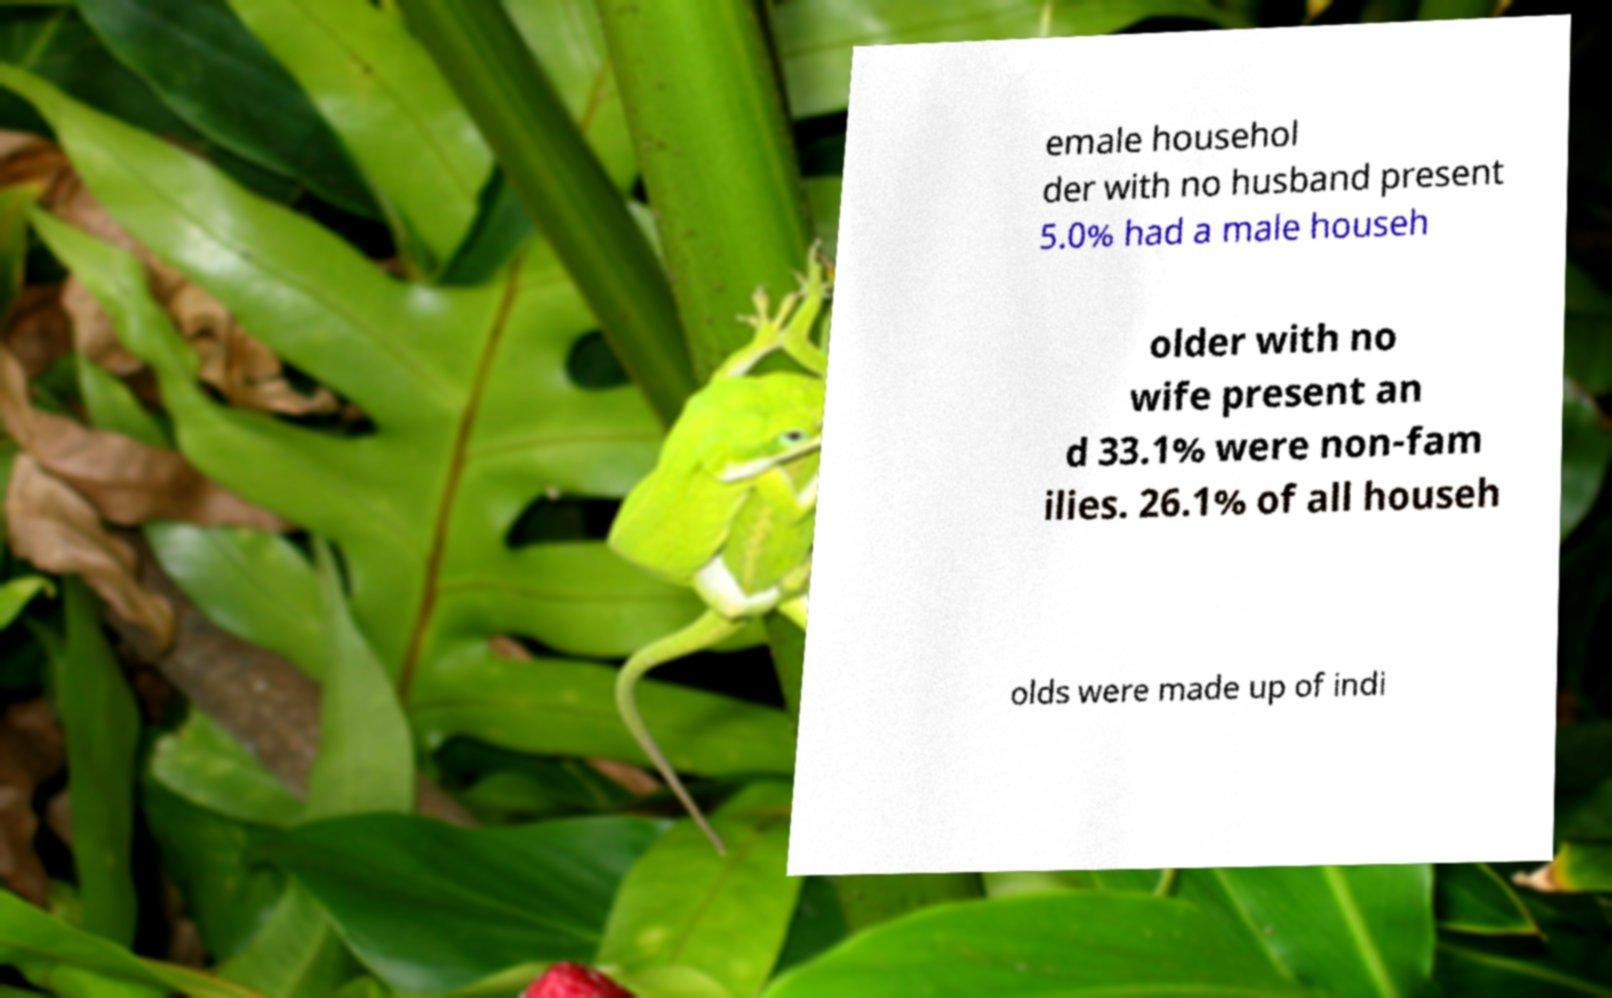Can you read and provide the text displayed in the image?This photo seems to have some interesting text. Can you extract and type it out for me? emale househol der with no husband present 5.0% had a male househ older with no wife present an d 33.1% were non-fam ilies. 26.1% of all househ olds were made up of indi 